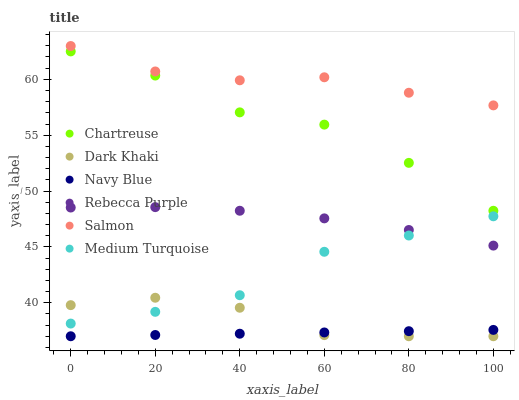Does Navy Blue have the minimum area under the curve?
Answer yes or no. Yes. Does Salmon have the maximum area under the curve?
Answer yes or no. Yes. Does Dark Khaki have the minimum area under the curve?
Answer yes or no. No. Does Dark Khaki have the maximum area under the curve?
Answer yes or no. No. Is Navy Blue the smoothest?
Answer yes or no. Yes. Is Chartreuse the roughest?
Answer yes or no. Yes. Is Salmon the smoothest?
Answer yes or no. No. Is Salmon the roughest?
Answer yes or no. No. Does Navy Blue have the lowest value?
Answer yes or no. Yes. Does Salmon have the lowest value?
Answer yes or no. No. Does Salmon have the highest value?
Answer yes or no. Yes. Does Dark Khaki have the highest value?
Answer yes or no. No. Is Dark Khaki less than Salmon?
Answer yes or no. Yes. Is Salmon greater than Navy Blue?
Answer yes or no. Yes. Does Medium Turquoise intersect Dark Khaki?
Answer yes or no. Yes. Is Medium Turquoise less than Dark Khaki?
Answer yes or no. No. Is Medium Turquoise greater than Dark Khaki?
Answer yes or no. No. Does Dark Khaki intersect Salmon?
Answer yes or no. No. 